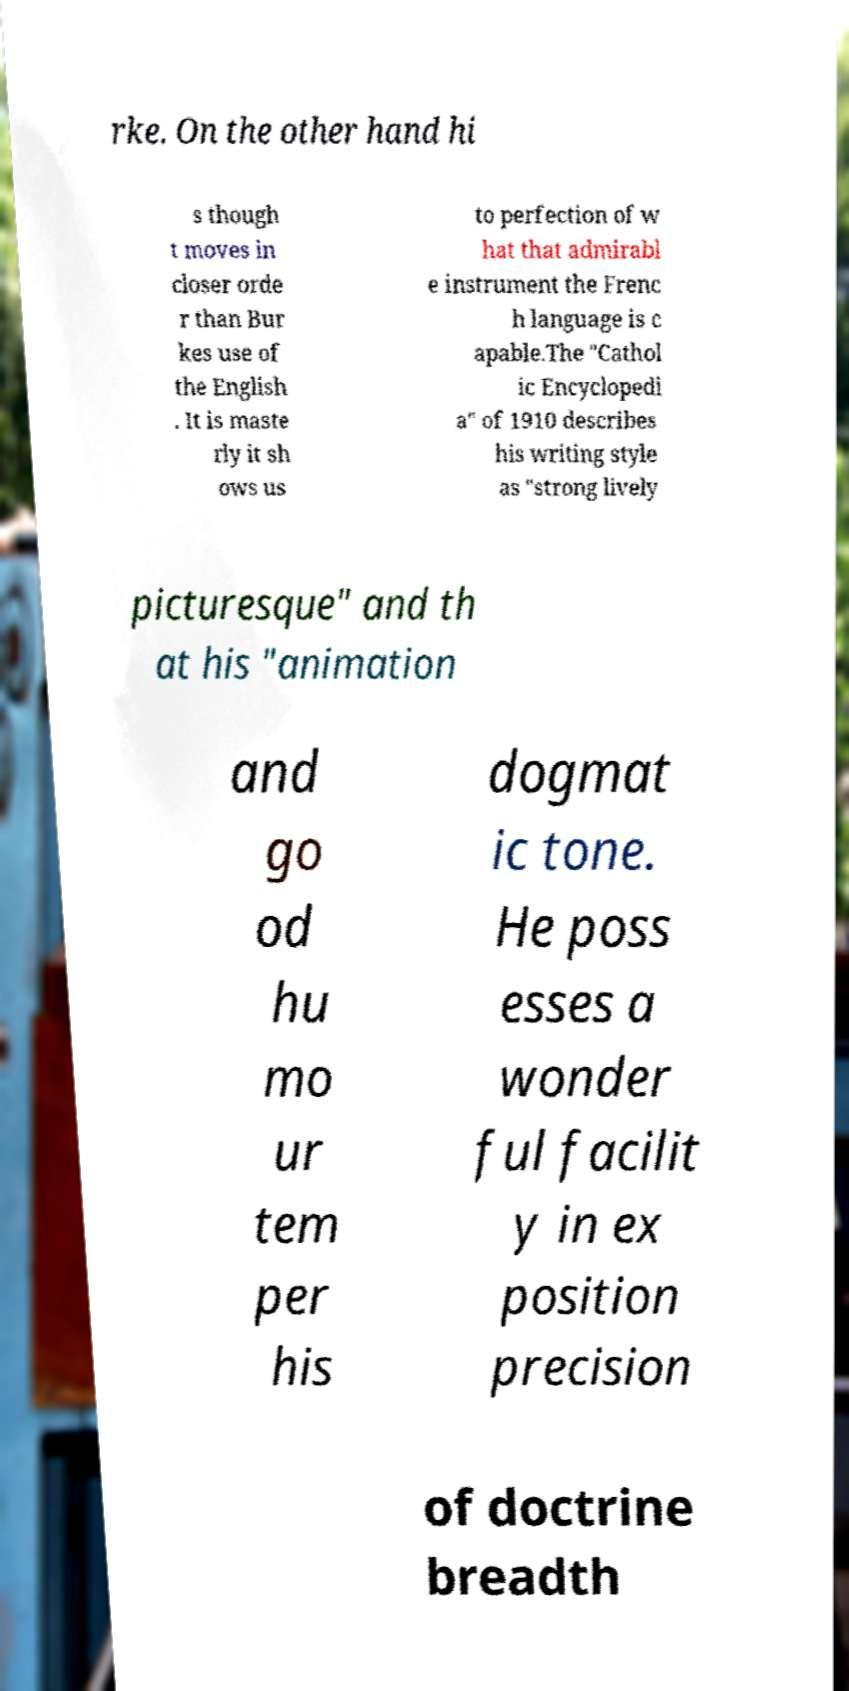Please read and relay the text visible in this image. What does it say? rke. On the other hand hi s though t moves in closer orde r than Bur kes use of the English . It is maste rly it sh ows us to perfection of w hat that admirabl e instrument the Frenc h language is c apable.The "Cathol ic Encyclopedi a" of 1910 describes his writing style as "strong lively picturesque" and th at his "animation and go od hu mo ur tem per his dogmat ic tone. He poss esses a wonder ful facilit y in ex position precision of doctrine breadth 